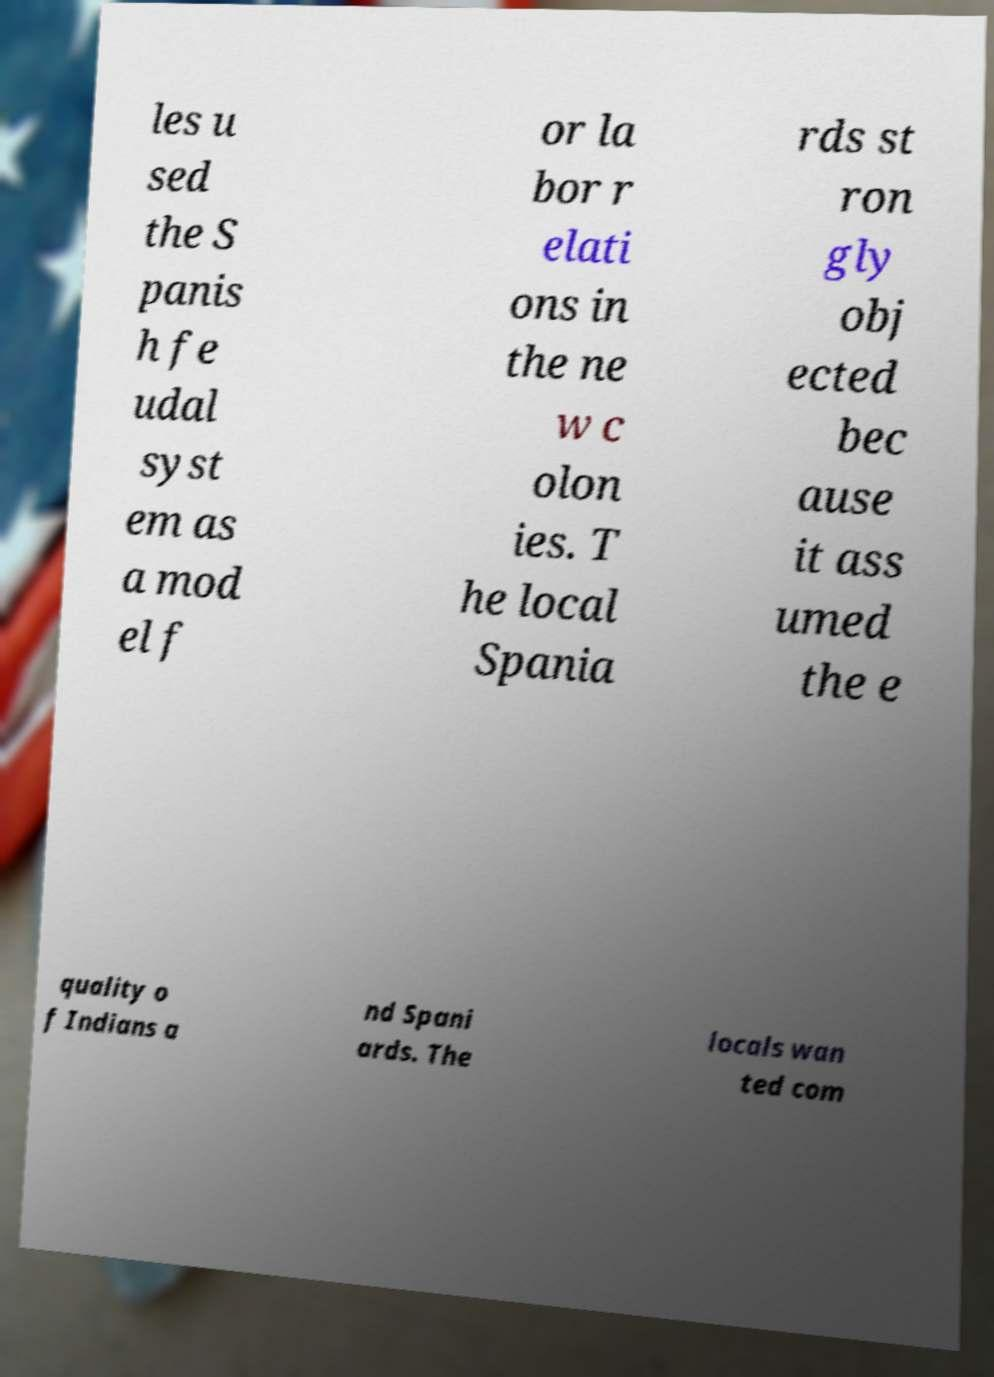Please read and relay the text visible in this image. What does it say? les u sed the S panis h fe udal syst em as a mod el f or la bor r elati ons in the ne w c olon ies. T he local Spania rds st ron gly obj ected bec ause it ass umed the e quality o f Indians a nd Spani ards. The locals wan ted com 